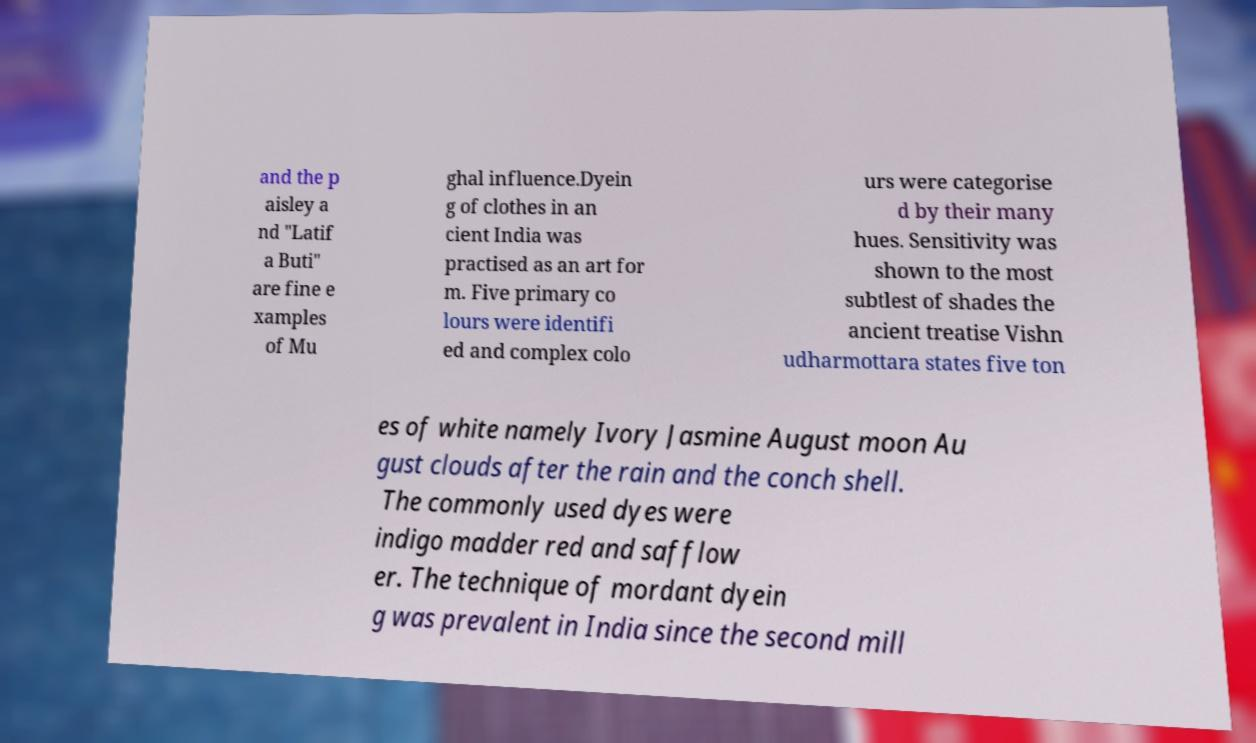Could you extract and type out the text from this image? and the p aisley a nd "Latif a Buti" are fine e xamples of Mu ghal influence.Dyein g of clothes in an cient India was practised as an art for m. Five primary co lours were identifi ed and complex colo urs were categorise d by their many hues. Sensitivity was shown to the most subtlest of shades the ancient treatise Vishn udharmottara states five ton es of white namely Ivory Jasmine August moon Au gust clouds after the rain and the conch shell. The commonly used dyes were indigo madder red and safflow er. The technique of mordant dyein g was prevalent in India since the second mill 